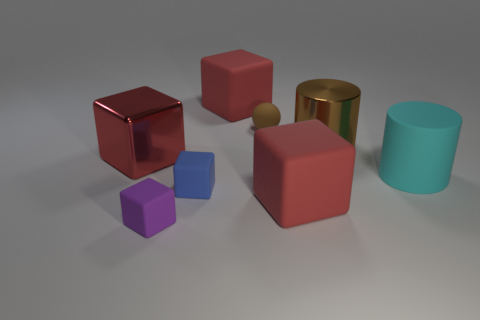Subtract all purple cylinders. How many red blocks are left? 3 Subtract all purple cubes. How many cubes are left? 4 Subtract all purple matte blocks. How many blocks are left? 4 Subtract 2 cubes. How many cubes are left? 3 Subtract all green blocks. Subtract all brown spheres. How many blocks are left? 5 Add 1 red rubber cylinders. How many objects exist? 9 Subtract all blocks. How many objects are left? 3 Subtract all small matte balls. Subtract all large red shiny things. How many objects are left? 6 Add 2 large shiny cylinders. How many large shiny cylinders are left? 3 Add 4 big things. How many big things exist? 9 